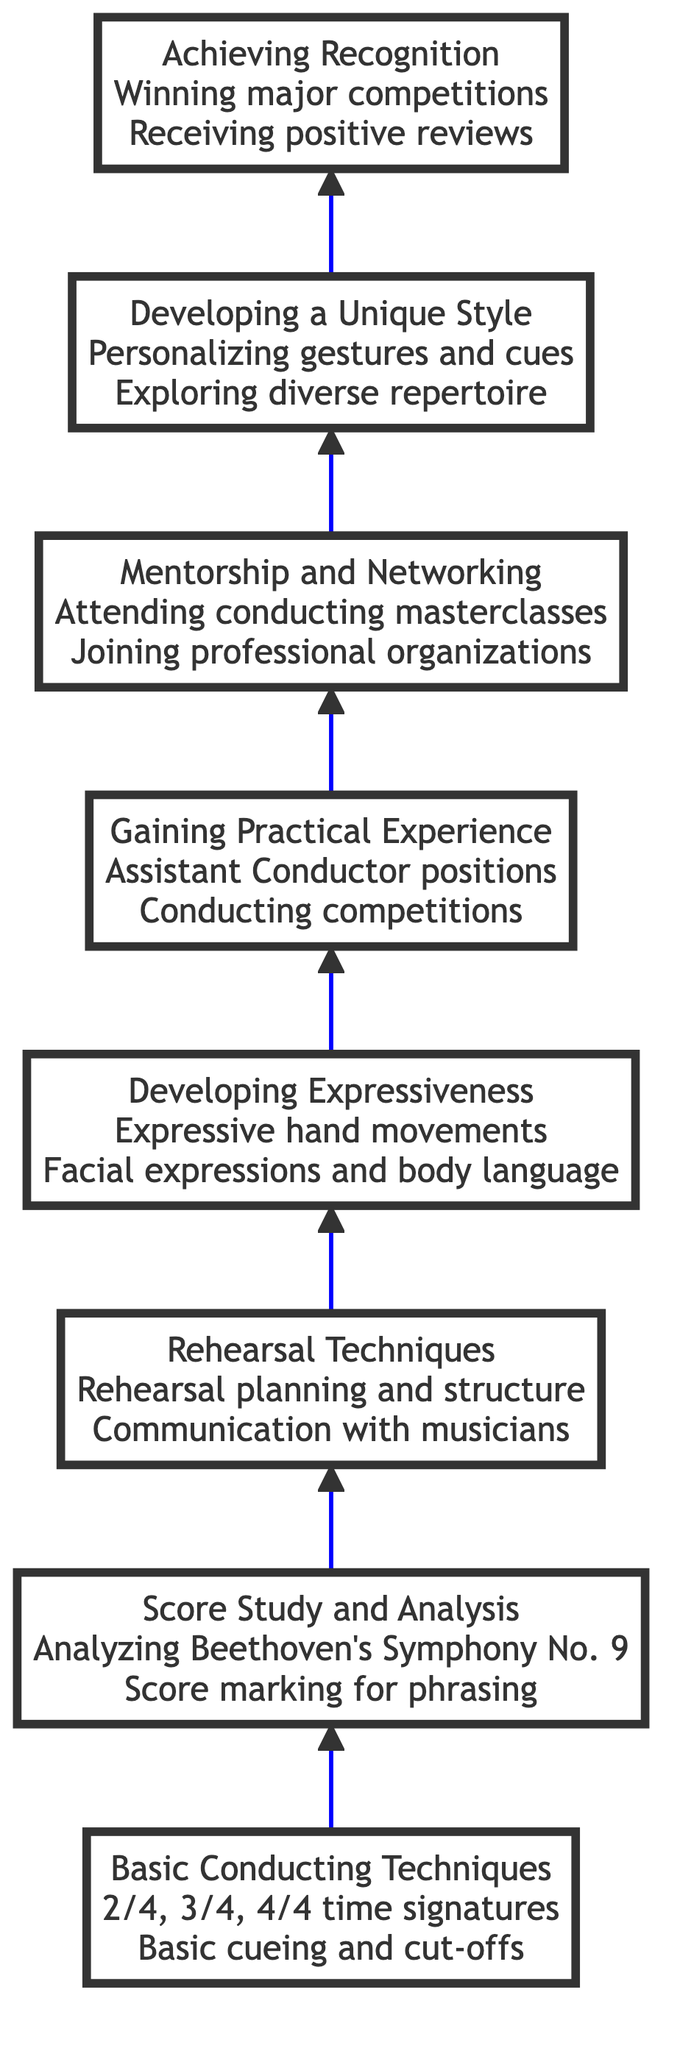What is the title of the first level? The first level is labeled as "Basic Conducting Techniques," which provides insight into the initial focus of the flow from bottom to top.
Answer: Basic Conducting Techniques How many levels are there in the diagram? By counting the distinct levels from the bottom (Basic Conducting Techniques) to the top (Achieving Recognition), I find there are a total of eight levels in the diagram.
Answer: 8 What is the relationship between 'Developing Expressiveness' and 'Gaining Practical Experience'? 'Developing Expressiveness' is located directly below 'Gaining Practical Experience' in the flow chart, indicating that expressiveness is a prerequisite for gaining real-world experience as a conductor.
Answer: Developing Expressiveness is below Gaining Practical Experience Which level focuses on mentorship and networking? The sixth level is specifically titled "Mentorship and Networking," highlighting its importance in the personal growth path of a conductor.
Answer: Mentorship and Networking What is one example of practical experience mentioned in the diagram? The diagram lists "Assistant Conductor positions" as an example under the "Gaining Practical Experience" level, demonstrating a way to apply conducting skills.
Answer: Assistant Conductor positions What skill is emphasized before 'Developing a Unique Style'? The skill emphasized before 'Developing a Unique Style' is 'Mentorship and Networking,' suggesting that building relationships is essential to developing one's distinct conducting style.
Answer: Mentorship and Networking What is the highest level of achievement indicated in the chart? The highest level in the flowchart is "Achieving Recognition," which signifies the culmination of efforts in the conductor's development journey.
Answer: Achieving Recognition How does 'Score Study and Analysis' contribute to 'Rehearsal Techniques'? 'Score Study and Analysis' enhances 'Rehearsal Techniques' by preparing the conductor to interpret scores effectively, which is crucial when leading rehearsals.
Answer: Score Study and Analysis enhances Rehearsal Techniques What does the flow from bottom to top indicate about the progression of a conductor’s development? The upward flow suggests an increasing complexity and depth in the learning process, starting from basic skills and progressing to achieving recognition in the field.
Answer: Increasing complexity and depth in learning process 